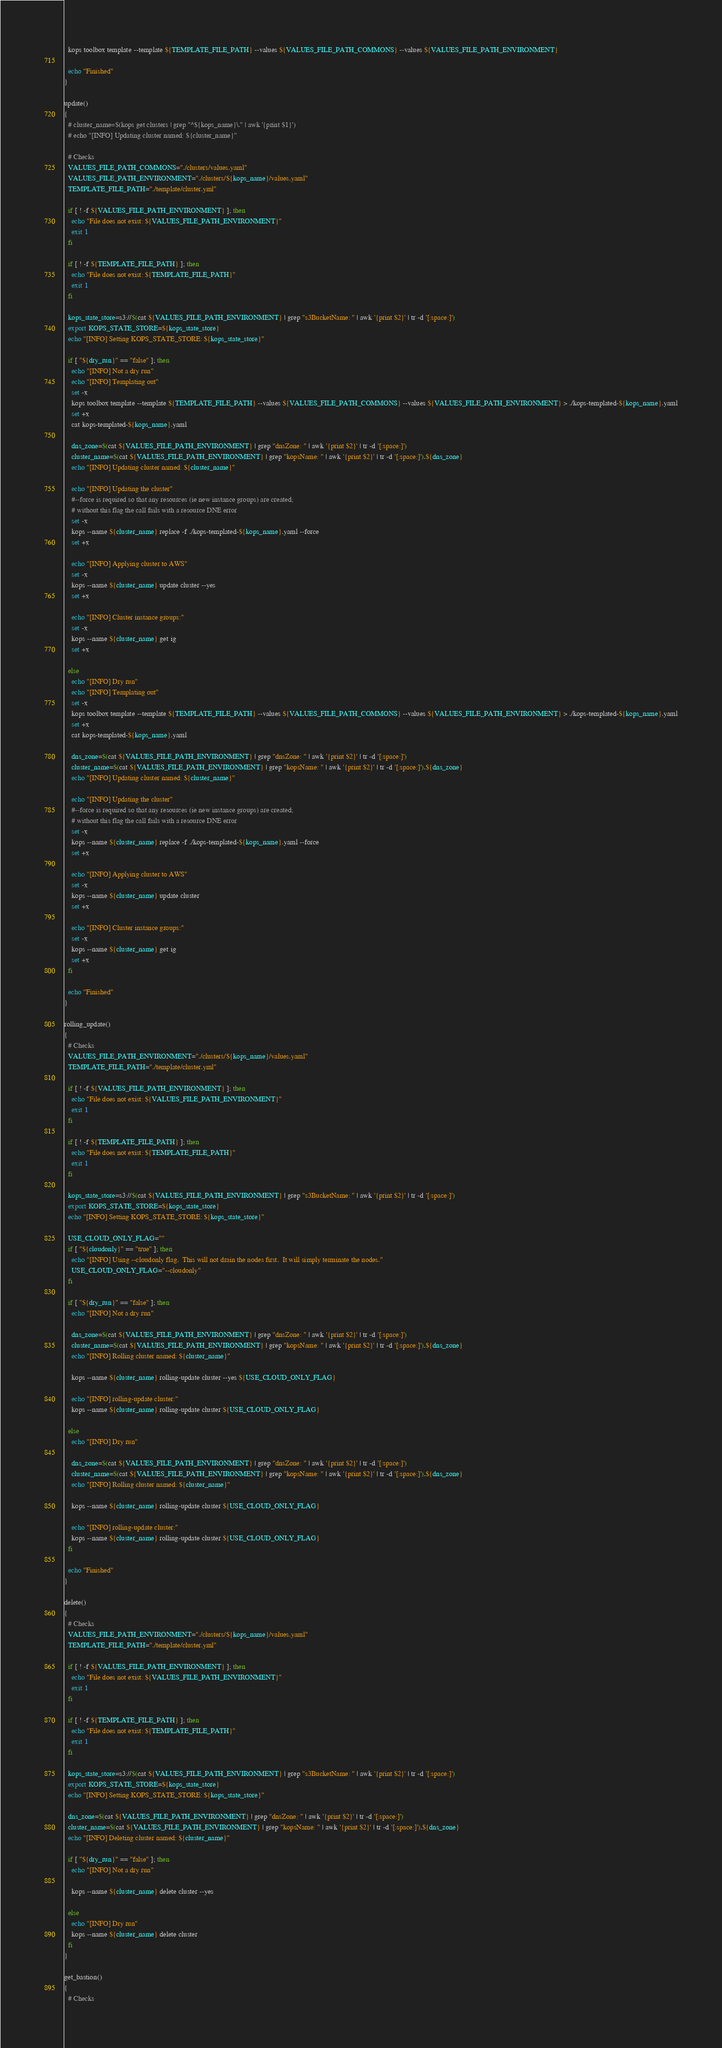Convert code to text. <code><loc_0><loc_0><loc_500><loc_500><_Bash_>  kops toolbox template --template ${TEMPLATE_FILE_PATH} --values ${VALUES_FILE_PATH_COMMONS} --values ${VALUES_FILE_PATH_ENVIRONMENT}

  echo "Finished"
}

update()
{
  # cluster_name=$(kops get clusters | grep "^${kops_name}\." | awk '{print $1}')
  # echo "[INFO] Updating cluster named: ${cluster_name}"

  # Checks
  VALUES_FILE_PATH_COMMONS="./clusters/values.yaml"
  VALUES_FILE_PATH_ENVIRONMENT="./clusters/${kops_name}/values.yaml"
  TEMPLATE_FILE_PATH="./template/cluster.yml"

  if [ ! -f ${VALUES_FILE_PATH_ENVIRONMENT} ]; then
    echo "File does not exist: ${VALUES_FILE_PATH_ENVIRONMENT}"
    exit 1
  fi

  if [ ! -f ${TEMPLATE_FILE_PATH} ]; then
    echo "File does not exist: ${TEMPLATE_FILE_PATH}"
    exit 1
  fi

  kops_state_store=s3://$(cat ${VALUES_FILE_PATH_ENVIRONMENT} | grep "s3BucketName: " | awk '{print $2}' | tr -d '[:space:]')
  export KOPS_STATE_STORE=${kops_state_store}
  echo "[INFO] Setting KOPS_STATE_STORE: ${kops_state_store}"

  if [ "${dry_run}" == "false" ]; then
    echo "[INFO] Not a dry run"
    echo "[INFO] Templating out"
    set -x
    kops toolbox template --template ${TEMPLATE_FILE_PATH} --values ${VALUES_FILE_PATH_COMMONS} --values ${VALUES_FILE_PATH_ENVIRONMENT} > ./kops-templated-${kops_name}.yaml
    set +x
    cat kops-templated-${kops_name}.yaml

    dns_zone=$(cat ${VALUES_FILE_PATH_ENVIRONMENT} | grep "dnsZone: " | awk '{print $2}' | tr -d '[:space:]')
    cluster_name=$(cat ${VALUES_FILE_PATH_ENVIRONMENT} | grep "kopsName: " | awk '{print $2}' | tr -d '[:space:]').${dns_zone}
    echo "[INFO] Updating cluster named: ${cluster_name}"

    echo "[INFO] Updating the cluster"
    #--force is required so that any resources (ie new instance groups) are created;
    # without this flag the call fails with a resource DNE error
    set -x
    kops --name ${cluster_name} replace -f ./kops-templated-${kops_name}.yaml --force
    set +x

    echo "[INFO] Applying cluster to AWS"
    set -x
    kops --name ${cluster_name} update cluster --yes
    set +x

    echo "[INFO] Cluster instance groups:"
    set -x
    kops --name ${cluster_name} get ig
    set +x

  else
    echo "[INFO] Dry run"
    echo "[INFO] Templating out"
    set -x
    kops toolbox template --template ${TEMPLATE_FILE_PATH} --values ${VALUES_FILE_PATH_COMMONS} --values ${VALUES_FILE_PATH_ENVIRONMENT} > ./kops-templated-${kops_name}.yaml
    set +x
    cat kops-templated-${kops_name}.yaml

    dns_zone=$(cat ${VALUES_FILE_PATH_ENVIRONMENT} | grep "dnsZone: " | awk '{print $2}' | tr -d '[:space:]')
    cluster_name=$(cat ${VALUES_FILE_PATH_ENVIRONMENT} | grep "kopsName: " | awk '{print $2}' | tr -d '[:space:]').${dns_zone}
    echo "[INFO] Updating cluster named: ${cluster_name}"

    echo "[INFO] Updating the cluster"
    #--force is required so that any resources (ie new instance groups) are created;
    # without this flag the call fails with a resource DNE error
    set -x
    kops --name ${cluster_name} replace -f ./kops-templated-${kops_name}.yaml --force
    set +x

    echo "[INFO] Applying cluster to AWS"
    set -x
    kops --name ${cluster_name} update cluster
    set +x

    echo "[INFO] Cluster instance groups:"
    set -x
    kops --name ${cluster_name} get ig
    set +x
  fi

  echo "Finished"
}

rolling_update()
{
  # Checks
  VALUES_FILE_PATH_ENVIRONMENT="./clusters/${kops_name}/values.yaml"
  TEMPLATE_FILE_PATH="./template/cluster.yml"

  if [ ! -f ${VALUES_FILE_PATH_ENVIRONMENT} ]; then
    echo "File does not exist: ${VALUES_FILE_PATH_ENVIRONMENT}"
    exit 1
  fi

  if [ ! -f ${TEMPLATE_FILE_PATH} ]; then
    echo "File does not exist: ${TEMPLATE_FILE_PATH}"
    exit 1
  fi

  kops_state_store=s3://$(cat ${VALUES_FILE_PATH_ENVIRONMENT} | grep "s3BucketName: " | awk '{print $2}' | tr -d '[:space:]')
  export KOPS_STATE_STORE=${kops_state_store}
  echo "[INFO] Setting KOPS_STATE_STORE: ${kops_state_store}"

  USE_CLOUD_ONLY_FLAG=""
  if [ "${cloudonly}" == "true" ]; then
    echo "[INFO] Using --cloudonly flag.  This will not drain the nodes first.  It will simply terminate the nodes."
    USE_CLOUD_ONLY_FLAG="--cloudonly"
  fi

  if [ "${dry_run}" == "false" ]; then
    echo "[INFO] Not a dry run"

    dns_zone=$(cat ${VALUES_FILE_PATH_ENVIRONMENT} | grep "dnsZone: " | awk '{print $2}' | tr -d '[:space:]')
    cluster_name=$(cat ${VALUES_FILE_PATH_ENVIRONMENT} | grep "kopsName: " | awk '{print $2}' | tr -d '[:space:]').${dns_zone}
    echo "[INFO] Rolling cluster named: ${cluster_name}"

    kops --name ${cluster_name} rolling-update cluster --yes ${USE_CLOUD_ONLY_FLAG}

    echo "[INFO] rolling-update cluster:"
    kops --name ${cluster_name} rolling-update cluster ${USE_CLOUD_ONLY_FLAG}

  else
    echo "[INFO] Dry run"

    dns_zone=$(cat ${VALUES_FILE_PATH_ENVIRONMENT} | grep "dnsZone: " | awk '{print $2}' | tr -d '[:space:]')
    cluster_name=$(cat ${VALUES_FILE_PATH_ENVIRONMENT} | grep "kopsName: " | awk '{print $2}' | tr -d '[:space:]').${dns_zone}
    echo "[INFO] Rolling cluster named: ${cluster_name}"

    kops --name ${cluster_name} rolling-update cluster ${USE_CLOUD_ONLY_FLAG}

    echo "[INFO] rolling-update cluster:"
    kops --name ${cluster_name} rolling-update cluster ${USE_CLOUD_ONLY_FLAG}
  fi

  echo "Finished"
}

delete()
{
  # Checks
  VALUES_FILE_PATH_ENVIRONMENT="./clusters/${kops_name}/values.yaml"
  TEMPLATE_FILE_PATH="./template/cluster.yml"

  if [ ! -f ${VALUES_FILE_PATH_ENVIRONMENT} ]; then
    echo "File does not exist: ${VALUES_FILE_PATH_ENVIRONMENT}"
    exit 1
  fi

  if [ ! -f ${TEMPLATE_FILE_PATH} ]; then
    echo "File does not exist: ${TEMPLATE_FILE_PATH}"
    exit 1
  fi

  kops_state_store=s3://$(cat ${VALUES_FILE_PATH_ENVIRONMENT} | grep "s3BucketName: " | awk '{print $2}' | tr -d '[:space:]')
  export KOPS_STATE_STORE=${kops_state_store}
  echo "[INFO] Setting KOPS_STATE_STORE: ${kops_state_store}"

  dns_zone=$(cat ${VALUES_FILE_PATH_ENVIRONMENT} | grep "dnsZone: " | awk '{print $2}' | tr -d '[:space:]')
  cluster_name=$(cat ${VALUES_FILE_PATH_ENVIRONMENT} | grep "kopsName: " | awk '{print $2}' | tr -d '[:space:]').${dns_zone}
  echo "[INFO] Deleting cluster named: ${cluster_name}"

  if [ "${dry_run}" == "false" ]; then
    echo "[INFO] Not a dry run"

    kops --name ${cluster_name} delete cluster --yes

  else
    echo "[INFO] Dry run"
    kops --name ${cluster_name} delete cluster
  fi
}

get_bastion()
{
  # Checks</code> 